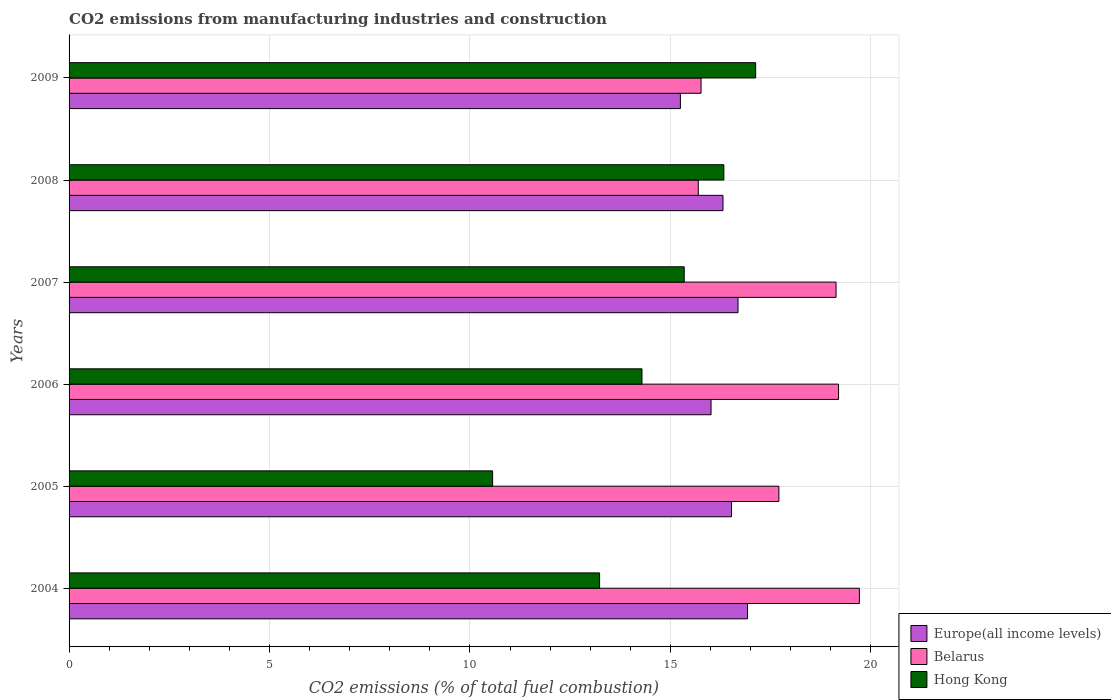How many groups of bars are there?
Provide a succinct answer. 6. How many bars are there on the 6th tick from the top?
Provide a succinct answer. 3. What is the label of the 4th group of bars from the top?
Your response must be concise. 2006. In how many cases, is the number of bars for a given year not equal to the number of legend labels?
Offer a terse response. 0. What is the amount of CO2 emitted in Hong Kong in 2006?
Your answer should be very brief. 14.29. Across all years, what is the maximum amount of CO2 emitted in Hong Kong?
Your answer should be very brief. 17.13. Across all years, what is the minimum amount of CO2 emitted in Belarus?
Ensure brevity in your answer.  15.7. In which year was the amount of CO2 emitted in Belarus minimum?
Keep it short and to the point. 2008. What is the total amount of CO2 emitted in Europe(all income levels) in the graph?
Offer a terse response. 97.72. What is the difference between the amount of CO2 emitted in Europe(all income levels) in 2004 and that in 2007?
Make the answer very short. 0.24. What is the difference between the amount of CO2 emitted in Europe(all income levels) in 2009 and the amount of CO2 emitted in Belarus in 2008?
Give a very brief answer. -0.45. What is the average amount of CO2 emitted in Europe(all income levels) per year?
Ensure brevity in your answer.  16.29. In the year 2005, what is the difference between the amount of CO2 emitted in Europe(all income levels) and amount of CO2 emitted in Hong Kong?
Your response must be concise. 5.96. In how many years, is the amount of CO2 emitted in Europe(all income levels) greater than 19 %?
Provide a succinct answer. 0. What is the ratio of the amount of CO2 emitted in Hong Kong in 2005 to that in 2009?
Give a very brief answer. 0.62. Is the amount of CO2 emitted in Europe(all income levels) in 2005 less than that in 2006?
Ensure brevity in your answer.  No. Is the difference between the amount of CO2 emitted in Europe(all income levels) in 2004 and 2006 greater than the difference between the amount of CO2 emitted in Hong Kong in 2004 and 2006?
Your answer should be very brief. Yes. What is the difference between the highest and the second highest amount of CO2 emitted in Hong Kong?
Give a very brief answer. 0.79. What is the difference between the highest and the lowest amount of CO2 emitted in Europe(all income levels)?
Give a very brief answer. 1.67. In how many years, is the amount of CO2 emitted in Hong Kong greater than the average amount of CO2 emitted in Hong Kong taken over all years?
Your response must be concise. 3. What does the 3rd bar from the top in 2009 represents?
Offer a terse response. Europe(all income levels). What does the 2nd bar from the bottom in 2009 represents?
Your answer should be compact. Belarus. Is it the case that in every year, the sum of the amount of CO2 emitted in Hong Kong and amount of CO2 emitted in Belarus is greater than the amount of CO2 emitted in Europe(all income levels)?
Offer a terse response. Yes. How many years are there in the graph?
Your answer should be very brief. 6. What is the difference between two consecutive major ticks on the X-axis?
Offer a very short reply. 5. How many legend labels are there?
Your answer should be very brief. 3. What is the title of the graph?
Offer a terse response. CO2 emissions from manufacturing industries and construction. What is the label or title of the X-axis?
Your response must be concise. CO2 emissions (% of total fuel combustion). What is the CO2 emissions (% of total fuel combustion) of Europe(all income levels) in 2004?
Provide a short and direct response. 16.93. What is the CO2 emissions (% of total fuel combustion) in Belarus in 2004?
Your response must be concise. 19.72. What is the CO2 emissions (% of total fuel combustion) of Hong Kong in 2004?
Ensure brevity in your answer.  13.24. What is the CO2 emissions (% of total fuel combustion) in Europe(all income levels) in 2005?
Offer a terse response. 16.53. What is the CO2 emissions (% of total fuel combustion) in Belarus in 2005?
Offer a terse response. 17.71. What is the CO2 emissions (% of total fuel combustion) in Hong Kong in 2005?
Offer a very short reply. 10.57. What is the CO2 emissions (% of total fuel combustion) of Europe(all income levels) in 2006?
Make the answer very short. 16.02. What is the CO2 emissions (% of total fuel combustion) in Belarus in 2006?
Provide a succinct answer. 19.2. What is the CO2 emissions (% of total fuel combustion) of Hong Kong in 2006?
Ensure brevity in your answer.  14.29. What is the CO2 emissions (% of total fuel combustion) in Europe(all income levels) in 2007?
Your answer should be very brief. 16.69. What is the CO2 emissions (% of total fuel combustion) in Belarus in 2007?
Your response must be concise. 19.13. What is the CO2 emissions (% of total fuel combustion) in Hong Kong in 2007?
Ensure brevity in your answer.  15.35. What is the CO2 emissions (% of total fuel combustion) of Europe(all income levels) in 2008?
Provide a succinct answer. 16.31. What is the CO2 emissions (% of total fuel combustion) of Belarus in 2008?
Your answer should be compact. 15.7. What is the CO2 emissions (% of total fuel combustion) in Hong Kong in 2008?
Provide a succinct answer. 16.34. What is the CO2 emissions (% of total fuel combustion) of Europe(all income levels) in 2009?
Provide a short and direct response. 15.25. What is the CO2 emissions (% of total fuel combustion) of Belarus in 2009?
Your answer should be very brief. 15.77. What is the CO2 emissions (% of total fuel combustion) in Hong Kong in 2009?
Give a very brief answer. 17.13. Across all years, what is the maximum CO2 emissions (% of total fuel combustion) in Europe(all income levels)?
Offer a terse response. 16.93. Across all years, what is the maximum CO2 emissions (% of total fuel combustion) in Belarus?
Ensure brevity in your answer.  19.72. Across all years, what is the maximum CO2 emissions (% of total fuel combustion) of Hong Kong?
Offer a terse response. 17.13. Across all years, what is the minimum CO2 emissions (% of total fuel combustion) in Europe(all income levels)?
Ensure brevity in your answer.  15.25. Across all years, what is the minimum CO2 emissions (% of total fuel combustion) of Belarus?
Provide a short and direct response. 15.7. Across all years, what is the minimum CO2 emissions (% of total fuel combustion) in Hong Kong?
Give a very brief answer. 10.57. What is the total CO2 emissions (% of total fuel combustion) in Europe(all income levels) in the graph?
Keep it short and to the point. 97.72. What is the total CO2 emissions (% of total fuel combustion) of Belarus in the graph?
Provide a short and direct response. 107.22. What is the total CO2 emissions (% of total fuel combustion) of Hong Kong in the graph?
Ensure brevity in your answer.  86.9. What is the difference between the CO2 emissions (% of total fuel combustion) of Europe(all income levels) in 2004 and that in 2005?
Offer a very short reply. 0.4. What is the difference between the CO2 emissions (% of total fuel combustion) in Belarus in 2004 and that in 2005?
Give a very brief answer. 2.01. What is the difference between the CO2 emissions (% of total fuel combustion) in Hong Kong in 2004 and that in 2005?
Your response must be concise. 2.67. What is the difference between the CO2 emissions (% of total fuel combustion) in Europe(all income levels) in 2004 and that in 2006?
Keep it short and to the point. 0.91. What is the difference between the CO2 emissions (% of total fuel combustion) of Belarus in 2004 and that in 2006?
Give a very brief answer. 0.52. What is the difference between the CO2 emissions (% of total fuel combustion) of Hong Kong in 2004 and that in 2006?
Give a very brief answer. -1.06. What is the difference between the CO2 emissions (% of total fuel combustion) in Europe(all income levels) in 2004 and that in 2007?
Provide a succinct answer. 0.24. What is the difference between the CO2 emissions (% of total fuel combustion) in Belarus in 2004 and that in 2007?
Keep it short and to the point. 0.58. What is the difference between the CO2 emissions (% of total fuel combustion) in Hong Kong in 2004 and that in 2007?
Provide a succinct answer. -2.11. What is the difference between the CO2 emissions (% of total fuel combustion) of Europe(all income levels) in 2004 and that in 2008?
Your response must be concise. 0.61. What is the difference between the CO2 emissions (% of total fuel combustion) of Belarus in 2004 and that in 2008?
Make the answer very short. 4.02. What is the difference between the CO2 emissions (% of total fuel combustion) of Hong Kong in 2004 and that in 2008?
Give a very brief answer. -3.1. What is the difference between the CO2 emissions (% of total fuel combustion) in Europe(all income levels) in 2004 and that in 2009?
Keep it short and to the point. 1.67. What is the difference between the CO2 emissions (% of total fuel combustion) in Belarus in 2004 and that in 2009?
Your answer should be compact. 3.95. What is the difference between the CO2 emissions (% of total fuel combustion) of Hong Kong in 2004 and that in 2009?
Keep it short and to the point. -3.89. What is the difference between the CO2 emissions (% of total fuel combustion) in Europe(all income levels) in 2005 and that in 2006?
Ensure brevity in your answer.  0.51. What is the difference between the CO2 emissions (% of total fuel combustion) of Belarus in 2005 and that in 2006?
Your answer should be compact. -1.49. What is the difference between the CO2 emissions (% of total fuel combustion) in Hong Kong in 2005 and that in 2006?
Make the answer very short. -3.73. What is the difference between the CO2 emissions (% of total fuel combustion) in Europe(all income levels) in 2005 and that in 2007?
Provide a succinct answer. -0.16. What is the difference between the CO2 emissions (% of total fuel combustion) in Belarus in 2005 and that in 2007?
Your response must be concise. -1.43. What is the difference between the CO2 emissions (% of total fuel combustion) of Hong Kong in 2005 and that in 2007?
Your answer should be very brief. -4.78. What is the difference between the CO2 emissions (% of total fuel combustion) in Europe(all income levels) in 2005 and that in 2008?
Offer a terse response. 0.21. What is the difference between the CO2 emissions (% of total fuel combustion) of Belarus in 2005 and that in 2008?
Provide a short and direct response. 2.01. What is the difference between the CO2 emissions (% of total fuel combustion) in Hong Kong in 2005 and that in 2008?
Offer a very short reply. -5.77. What is the difference between the CO2 emissions (% of total fuel combustion) of Europe(all income levels) in 2005 and that in 2009?
Keep it short and to the point. 1.27. What is the difference between the CO2 emissions (% of total fuel combustion) in Belarus in 2005 and that in 2009?
Offer a very short reply. 1.94. What is the difference between the CO2 emissions (% of total fuel combustion) in Hong Kong in 2005 and that in 2009?
Offer a terse response. -6.56. What is the difference between the CO2 emissions (% of total fuel combustion) of Europe(all income levels) in 2006 and that in 2007?
Provide a succinct answer. -0.67. What is the difference between the CO2 emissions (% of total fuel combustion) of Belarus in 2006 and that in 2007?
Offer a terse response. 0.06. What is the difference between the CO2 emissions (% of total fuel combustion) of Hong Kong in 2006 and that in 2007?
Make the answer very short. -1.05. What is the difference between the CO2 emissions (% of total fuel combustion) of Europe(all income levels) in 2006 and that in 2008?
Offer a terse response. -0.3. What is the difference between the CO2 emissions (% of total fuel combustion) of Belarus in 2006 and that in 2008?
Your answer should be compact. 3.5. What is the difference between the CO2 emissions (% of total fuel combustion) in Hong Kong in 2006 and that in 2008?
Provide a succinct answer. -2.04. What is the difference between the CO2 emissions (% of total fuel combustion) in Europe(all income levels) in 2006 and that in 2009?
Provide a succinct answer. 0.76. What is the difference between the CO2 emissions (% of total fuel combustion) in Belarus in 2006 and that in 2009?
Offer a terse response. 3.43. What is the difference between the CO2 emissions (% of total fuel combustion) in Hong Kong in 2006 and that in 2009?
Keep it short and to the point. -2.84. What is the difference between the CO2 emissions (% of total fuel combustion) in Europe(all income levels) in 2007 and that in 2008?
Your response must be concise. 0.37. What is the difference between the CO2 emissions (% of total fuel combustion) in Belarus in 2007 and that in 2008?
Give a very brief answer. 3.44. What is the difference between the CO2 emissions (% of total fuel combustion) of Hong Kong in 2007 and that in 2008?
Offer a terse response. -0.99. What is the difference between the CO2 emissions (% of total fuel combustion) in Europe(all income levels) in 2007 and that in 2009?
Your answer should be very brief. 1.44. What is the difference between the CO2 emissions (% of total fuel combustion) in Belarus in 2007 and that in 2009?
Your answer should be compact. 3.37. What is the difference between the CO2 emissions (% of total fuel combustion) in Hong Kong in 2007 and that in 2009?
Offer a terse response. -1.78. What is the difference between the CO2 emissions (% of total fuel combustion) of Europe(all income levels) in 2008 and that in 2009?
Offer a terse response. 1.06. What is the difference between the CO2 emissions (% of total fuel combustion) in Belarus in 2008 and that in 2009?
Offer a very short reply. -0.07. What is the difference between the CO2 emissions (% of total fuel combustion) of Hong Kong in 2008 and that in 2009?
Ensure brevity in your answer.  -0.79. What is the difference between the CO2 emissions (% of total fuel combustion) of Europe(all income levels) in 2004 and the CO2 emissions (% of total fuel combustion) of Belarus in 2005?
Your response must be concise. -0.78. What is the difference between the CO2 emissions (% of total fuel combustion) in Europe(all income levels) in 2004 and the CO2 emissions (% of total fuel combustion) in Hong Kong in 2005?
Ensure brevity in your answer.  6.36. What is the difference between the CO2 emissions (% of total fuel combustion) of Belarus in 2004 and the CO2 emissions (% of total fuel combustion) of Hong Kong in 2005?
Your response must be concise. 9.15. What is the difference between the CO2 emissions (% of total fuel combustion) in Europe(all income levels) in 2004 and the CO2 emissions (% of total fuel combustion) in Belarus in 2006?
Your response must be concise. -2.27. What is the difference between the CO2 emissions (% of total fuel combustion) of Europe(all income levels) in 2004 and the CO2 emissions (% of total fuel combustion) of Hong Kong in 2006?
Offer a very short reply. 2.63. What is the difference between the CO2 emissions (% of total fuel combustion) of Belarus in 2004 and the CO2 emissions (% of total fuel combustion) of Hong Kong in 2006?
Your answer should be compact. 5.42. What is the difference between the CO2 emissions (% of total fuel combustion) of Europe(all income levels) in 2004 and the CO2 emissions (% of total fuel combustion) of Belarus in 2007?
Provide a short and direct response. -2.21. What is the difference between the CO2 emissions (% of total fuel combustion) of Europe(all income levels) in 2004 and the CO2 emissions (% of total fuel combustion) of Hong Kong in 2007?
Ensure brevity in your answer.  1.58. What is the difference between the CO2 emissions (% of total fuel combustion) in Belarus in 2004 and the CO2 emissions (% of total fuel combustion) in Hong Kong in 2007?
Offer a terse response. 4.37. What is the difference between the CO2 emissions (% of total fuel combustion) in Europe(all income levels) in 2004 and the CO2 emissions (% of total fuel combustion) in Belarus in 2008?
Your response must be concise. 1.23. What is the difference between the CO2 emissions (% of total fuel combustion) in Europe(all income levels) in 2004 and the CO2 emissions (% of total fuel combustion) in Hong Kong in 2008?
Give a very brief answer. 0.59. What is the difference between the CO2 emissions (% of total fuel combustion) in Belarus in 2004 and the CO2 emissions (% of total fuel combustion) in Hong Kong in 2008?
Provide a succinct answer. 3.38. What is the difference between the CO2 emissions (% of total fuel combustion) in Europe(all income levels) in 2004 and the CO2 emissions (% of total fuel combustion) in Belarus in 2009?
Your answer should be compact. 1.16. What is the difference between the CO2 emissions (% of total fuel combustion) of Europe(all income levels) in 2004 and the CO2 emissions (% of total fuel combustion) of Hong Kong in 2009?
Offer a terse response. -0.2. What is the difference between the CO2 emissions (% of total fuel combustion) of Belarus in 2004 and the CO2 emissions (% of total fuel combustion) of Hong Kong in 2009?
Your response must be concise. 2.59. What is the difference between the CO2 emissions (% of total fuel combustion) in Europe(all income levels) in 2005 and the CO2 emissions (% of total fuel combustion) in Belarus in 2006?
Provide a short and direct response. -2.67. What is the difference between the CO2 emissions (% of total fuel combustion) in Europe(all income levels) in 2005 and the CO2 emissions (% of total fuel combustion) in Hong Kong in 2006?
Ensure brevity in your answer.  2.23. What is the difference between the CO2 emissions (% of total fuel combustion) of Belarus in 2005 and the CO2 emissions (% of total fuel combustion) of Hong Kong in 2006?
Ensure brevity in your answer.  3.42. What is the difference between the CO2 emissions (% of total fuel combustion) of Europe(all income levels) in 2005 and the CO2 emissions (% of total fuel combustion) of Belarus in 2007?
Make the answer very short. -2.61. What is the difference between the CO2 emissions (% of total fuel combustion) in Europe(all income levels) in 2005 and the CO2 emissions (% of total fuel combustion) in Hong Kong in 2007?
Provide a short and direct response. 1.18. What is the difference between the CO2 emissions (% of total fuel combustion) in Belarus in 2005 and the CO2 emissions (% of total fuel combustion) in Hong Kong in 2007?
Ensure brevity in your answer.  2.36. What is the difference between the CO2 emissions (% of total fuel combustion) of Europe(all income levels) in 2005 and the CO2 emissions (% of total fuel combustion) of Belarus in 2008?
Your answer should be very brief. 0.83. What is the difference between the CO2 emissions (% of total fuel combustion) in Europe(all income levels) in 2005 and the CO2 emissions (% of total fuel combustion) in Hong Kong in 2008?
Your answer should be very brief. 0.19. What is the difference between the CO2 emissions (% of total fuel combustion) of Belarus in 2005 and the CO2 emissions (% of total fuel combustion) of Hong Kong in 2008?
Provide a succinct answer. 1.37. What is the difference between the CO2 emissions (% of total fuel combustion) of Europe(all income levels) in 2005 and the CO2 emissions (% of total fuel combustion) of Belarus in 2009?
Your answer should be compact. 0.76. What is the difference between the CO2 emissions (% of total fuel combustion) of Europe(all income levels) in 2005 and the CO2 emissions (% of total fuel combustion) of Hong Kong in 2009?
Your response must be concise. -0.6. What is the difference between the CO2 emissions (% of total fuel combustion) in Belarus in 2005 and the CO2 emissions (% of total fuel combustion) in Hong Kong in 2009?
Your answer should be compact. 0.58. What is the difference between the CO2 emissions (% of total fuel combustion) in Europe(all income levels) in 2006 and the CO2 emissions (% of total fuel combustion) in Belarus in 2007?
Your answer should be very brief. -3.12. What is the difference between the CO2 emissions (% of total fuel combustion) in Europe(all income levels) in 2006 and the CO2 emissions (% of total fuel combustion) in Hong Kong in 2007?
Provide a succinct answer. 0.67. What is the difference between the CO2 emissions (% of total fuel combustion) of Belarus in 2006 and the CO2 emissions (% of total fuel combustion) of Hong Kong in 2007?
Make the answer very short. 3.85. What is the difference between the CO2 emissions (% of total fuel combustion) in Europe(all income levels) in 2006 and the CO2 emissions (% of total fuel combustion) in Belarus in 2008?
Make the answer very short. 0.32. What is the difference between the CO2 emissions (% of total fuel combustion) in Europe(all income levels) in 2006 and the CO2 emissions (% of total fuel combustion) in Hong Kong in 2008?
Provide a short and direct response. -0.32. What is the difference between the CO2 emissions (% of total fuel combustion) in Belarus in 2006 and the CO2 emissions (% of total fuel combustion) in Hong Kong in 2008?
Offer a terse response. 2.86. What is the difference between the CO2 emissions (% of total fuel combustion) in Europe(all income levels) in 2006 and the CO2 emissions (% of total fuel combustion) in Belarus in 2009?
Ensure brevity in your answer.  0.25. What is the difference between the CO2 emissions (% of total fuel combustion) in Europe(all income levels) in 2006 and the CO2 emissions (% of total fuel combustion) in Hong Kong in 2009?
Ensure brevity in your answer.  -1.11. What is the difference between the CO2 emissions (% of total fuel combustion) in Belarus in 2006 and the CO2 emissions (% of total fuel combustion) in Hong Kong in 2009?
Your answer should be very brief. 2.07. What is the difference between the CO2 emissions (% of total fuel combustion) of Europe(all income levels) in 2007 and the CO2 emissions (% of total fuel combustion) of Belarus in 2008?
Your answer should be very brief. 0.99. What is the difference between the CO2 emissions (% of total fuel combustion) in Europe(all income levels) in 2007 and the CO2 emissions (% of total fuel combustion) in Hong Kong in 2008?
Offer a very short reply. 0.35. What is the difference between the CO2 emissions (% of total fuel combustion) in Belarus in 2007 and the CO2 emissions (% of total fuel combustion) in Hong Kong in 2008?
Your response must be concise. 2.8. What is the difference between the CO2 emissions (% of total fuel combustion) in Europe(all income levels) in 2007 and the CO2 emissions (% of total fuel combustion) in Belarus in 2009?
Offer a terse response. 0.92. What is the difference between the CO2 emissions (% of total fuel combustion) of Europe(all income levels) in 2007 and the CO2 emissions (% of total fuel combustion) of Hong Kong in 2009?
Provide a succinct answer. -0.44. What is the difference between the CO2 emissions (% of total fuel combustion) in Belarus in 2007 and the CO2 emissions (% of total fuel combustion) in Hong Kong in 2009?
Ensure brevity in your answer.  2.01. What is the difference between the CO2 emissions (% of total fuel combustion) of Europe(all income levels) in 2008 and the CO2 emissions (% of total fuel combustion) of Belarus in 2009?
Offer a terse response. 0.55. What is the difference between the CO2 emissions (% of total fuel combustion) in Europe(all income levels) in 2008 and the CO2 emissions (% of total fuel combustion) in Hong Kong in 2009?
Make the answer very short. -0.81. What is the difference between the CO2 emissions (% of total fuel combustion) in Belarus in 2008 and the CO2 emissions (% of total fuel combustion) in Hong Kong in 2009?
Your answer should be compact. -1.43. What is the average CO2 emissions (% of total fuel combustion) in Europe(all income levels) per year?
Provide a succinct answer. 16.29. What is the average CO2 emissions (% of total fuel combustion) of Belarus per year?
Keep it short and to the point. 17.87. What is the average CO2 emissions (% of total fuel combustion) in Hong Kong per year?
Make the answer very short. 14.48. In the year 2004, what is the difference between the CO2 emissions (% of total fuel combustion) in Europe(all income levels) and CO2 emissions (% of total fuel combustion) in Belarus?
Your answer should be very brief. -2.79. In the year 2004, what is the difference between the CO2 emissions (% of total fuel combustion) in Europe(all income levels) and CO2 emissions (% of total fuel combustion) in Hong Kong?
Your answer should be compact. 3.69. In the year 2004, what is the difference between the CO2 emissions (% of total fuel combustion) in Belarus and CO2 emissions (% of total fuel combustion) in Hong Kong?
Ensure brevity in your answer.  6.48. In the year 2005, what is the difference between the CO2 emissions (% of total fuel combustion) in Europe(all income levels) and CO2 emissions (% of total fuel combustion) in Belarus?
Your answer should be compact. -1.18. In the year 2005, what is the difference between the CO2 emissions (% of total fuel combustion) of Europe(all income levels) and CO2 emissions (% of total fuel combustion) of Hong Kong?
Offer a very short reply. 5.96. In the year 2005, what is the difference between the CO2 emissions (% of total fuel combustion) in Belarus and CO2 emissions (% of total fuel combustion) in Hong Kong?
Make the answer very short. 7.14. In the year 2006, what is the difference between the CO2 emissions (% of total fuel combustion) of Europe(all income levels) and CO2 emissions (% of total fuel combustion) of Belarus?
Your answer should be very brief. -3.18. In the year 2006, what is the difference between the CO2 emissions (% of total fuel combustion) in Europe(all income levels) and CO2 emissions (% of total fuel combustion) in Hong Kong?
Give a very brief answer. 1.72. In the year 2006, what is the difference between the CO2 emissions (% of total fuel combustion) of Belarus and CO2 emissions (% of total fuel combustion) of Hong Kong?
Keep it short and to the point. 4.9. In the year 2007, what is the difference between the CO2 emissions (% of total fuel combustion) in Europe(all income levels) and CO2 emissions (% of total fuel combustion) in Belarus?
Give a very brief answer. -2.45. In the year 2007, what is the difference between the CO2 emissions (% of total fuel combustion) in Europe(all income levels) and CO2 emissions (% of total fuel combustion) in Hong Kong?
Your answer should be compact. 1.34. In the year 2007, what is the difference between the CO2 emissions (% of total fuel combustion) in Belarus and CO2 emissions (% of total fuel combustion) in Hong Kong?
Provide a succinct answer. 3.79. In the year 2008, what is the difference between the CO2 emissions (% of total fuel combustion) in Europe(all income levels) and CO2 emissions (% of total fuel combustion) in Belarus?
Provide a succinct answer. 0.62. In the year 2008, what is the difference between the CO2 emissions (% of total fuel combustion) of Europe(all income levels) and CO2 emissions (% of total fuel combustion) of Hong Kong?
Offer a very short reply. -0.02. In the year 2008, what is the difference between the CO2 emissions (% of total fuel combustion) in Belarus and CO2 emissions (% of total fuel combustion) in Hong Kong?
Keep it short and to the point. -0.64. In the year 2009, what is the difference between the CO2 emissions (% of total fuel combustion) of Europe(all income levels) and CO2 emissions (% of total fuel combustion) of Belarus?
Offer a terse response. -0.52. In the year 2009, what is the difference between the CO2 emissions (% of total fuel combustion) of Europe(all income levels) and CO2 emissions (% of total fuel combustion) of Hong Kong?
Your response must be concise. -1.88. In the year 2009, what is the difference between the CO2 emissions (% of total fuel combustion) in Belarus and CO2 emissions (% of total fuel combustion) in Hong Kong?
Provide a short and direct response. -1.36. What is the ratio of the CO2 emissions (% of total fuel combustion) of Europe(all income levels) in 2004 to that in 2005?
Keep it short and to the point. 1.02. What is the ratio of the CO2 emissions (% of total fuel combustion) of Belarus in 2004 to that in 2005?
Provide a succinct answer. 1.11. What is the ratio of the CO2 emissions (% of total fuel combustion) of Hong Kong in 2004 to that in 2005?
Your response must be concise. 1.25. What is the ratio of the CO2 emissions (% of total fuel combustion) in Europe(all income levels) in 2004 to that in 2006?
Ensure brevity in your answer.  1.06. What is the ratio of the CO2 emissions (% of total fuel combustion) of Belarus in 2004 to that in 2006?
Offer a very short reply. 1.03. What is the ratio of the CO2 emissions (% of total fuel combustion) in Hong Kong in 2004 to that in 2006?
Give a very brief answer. 0.93. What is the ratio of the CO2 emissions (% of total fuel combustion) in Europe(all income levels) in 2004 to that in 2007?
Your answer should be very brief. 1.01. What is the ratio of the CO2 emissions (% of total fuel combustion) in Belarus in 2004 to that in 2007?
Offer a terse response. 1.03. What is the ratio of the CO2 emissions (% of total fuel combustion) in Hong Kong in 2004 to that in 2007?
Your answer should be compact. 0.86. What is the ratio of the CO2 emissions (% of total fuel combustion) of Europe(all income levels) in 2004 to that in 2008?
Keep it short and to the point. 1.04. What is the ratio of the CO2 emissions (% of total fuel combustion) in Belarus in 2004 to that in 2008?
Your response must be concise. 1.26. What is the ratio of the CO2 emissions (% of total fuel combustion) in Hong Kong in 2004 to that in 2008?
Offer a very short reply. 0.81. What is the ratio of the CO2 emissions (% of total fuel combustion) of Europe(all income levels) in 2004 to that in 2009?
Offer a very short reply. 1.11. What is the ratio of the CO2 emissions (% of total fuel combustion) of Belarus in 2004 to that in 2009?
Provide a succinct answer. 1.25. What is the ratio of the CO2 emissions (% of total fuel combustion) of Hong Kong in 2004 to that in 2009?
Your answer should be very brief. 0.77. What is the ratio of the CO2 emissions (% of total fuel combustion) in Europe(all income levels) in 2005 to that in 2006?
Keep it short and to the point. 1.03. What is the ratio of the CO2 emissions (% of total fuel combustion) of Belarus in 2005 to that in 2006?
Provide a short and direct response. 0.92. What is the ratio of the CO2 emissions (% of total fuel combustion) in Hong Kong in 2005 to that in 2006?
Ensure brevity in your answer.  0.74. What is the ratio of the CO2 emissions (% of total fuel combustion) of Europe(all income levels) in 2005 to that in 2007?
Offer a very short reply. 0.99. What is the ratio of the CO2 emissions (% of total fuel combustion) of Belarus in 2005 to that in 2007?
Keep it short and to the point. 0.93. What is the ratio of the CO2 emissions (% of total fuel combustion) of Hong Kong in 2005 to that in 2007?
Your answer should be compact. 0.69. What is the ratio of the CO2 emissions (% of total fuel combustion) in Europe(all income levels) in 2005 to that in 2008?
Ensure brevity in your answer.  1.01. What is the ratio of the CO2 emissions (% of total fuel combustion) of Belarus in 2005 to that in 2008?
Provide a succinct answer. 1.13. What is the ratio of the CO2 emissions (% of total fuel combustion) of Hong Kong in 2005 to that in 2008?
Make the answer very short. 0.65. What is the ratio of the CO2 emissions (% of total fuel combustion) in Europe(all income levels) in 2005 to that in 2009?
Provide a short and direct response. 1.08. What is the ratio of the CO2 emissions (% of total fuel combustion) in Belarus in 2005 to that in 2009?
Give a very brief answer. 1.12. What is the ratio of the CO2 emissions (% of total fuel combustion) in Hong Kong in 2005 to that in 2009?
Provide a short and direct response. 0.62. What is the ratio of the CO2 emissions (% of total fuel combustion) of Europe(all income levels) in 2006 to that in 2007?
Your response must be concise. 0.96. What is the ratio of the CO2 emissions (% of total fuel combustion) in Belarus in 2006 to that in 2007?
Offer a terse response. 1. What is the ratio of the CO2 emissions (% of total fuel combustion) of Hong Kong in 2006 to that in 2007?
Provide a short and direct response. 0.93. What is the ratio of the CO2 emissions (% of total fuel combustion) in Europe(all income levels) in 2006 to that in 2008?
Ensure brevity in your answer.  0.98. What is the ratio of the CO2 emissions (% of total fuel combustion) of Belarus in 2006 to that in 2008?
Your answer should be very brief. 1.22. What is the ratio of the CO2 emissions (% of total fuel combustion) of Europe(all income levels) in 2006 to that in 2009?
Give a very brief answer. 1.05. What is the ratio of the CO2 emissions (% of total fuel combustion) in Belarus in 2006 to that in 2009?
Your answer should be very brief. 1.22. What is the ratio of the CO2 emissions (% of total fuel combustion) of Hong Kong in 2006 to that in 2009?
Your answer should be very brief. 0.83. What is the ratio of the CO2 emissions (% of total fuel combustion) of Europe(all income levels) in 2007 to that in 2008?
Your answer should be very brief. 1.02. What is the ratio of the CO2 emissions (% of total fuel combustion) of Belarus in 2007 to that in 2008?
Ensure brevity in your answer.  1.22. What is the ratio of the CO2 emissions (% of total fuel combustion) in Hong Kong in 2007 to that in 2008?
Your answer should be very brief. 0.94. What is the ratio of the CO2 emissions (% of total fuel combustion) in Europe(all income levels) in 2007 to that in 2009?
Provide a short and direct response. 1.09. What is the ratio of the CO2 emissions (% of total fuel combustion) of Belarus in 2007 to that in 2009?
Ensure brevity in your answer.  1.21. What is the ratio of the CO2 emissions (% of total fuel combustion) of Hong Kong in 2007 to that in 2009?
Provide a succinct answer. 0.9. What is the ratio of the CO2 emissions (% of total fuel combustion) in Europe(all income levels) in 2008 to that in 2009?
Make the answer very short. 1.07. What is the ratio of the CO2 emissions (% of total fuel combustion) of Hong Kong in 2008 to that in 2009?
Your response must be concise. 0.95. What is the difference between the highest and the second highest CO2 emissions (% of total fuel combustion) in Europe(all income levels)?
Ensure brevity in your answer.  0.24. What is the difference between the highest and the second highest CO2 emissions (% of total fuel combustion) of Belarus?
Provide a succinct answer. 0.52. What is the difference between the highest and the second highest CO2 emissions (% of total fuel combustion) in Hong Kong?
Provide a succinct answer. 0.79. What is the difference between the highest and the lowest CO2 emissions (% of total fuel combustion) in Europe(all income levels)?
Provide a short and direct response. 1.67. What is the difference between the highest and the lowest CO2 emissions (% of total fuel combustion) of Belarus?
Offer a very short reply. 4.02. What is the difference between the highest and the lowest CO2 emissions (% of total fuel combustion) in Hong Kong?
Provide a succinct answer. 6.56. 